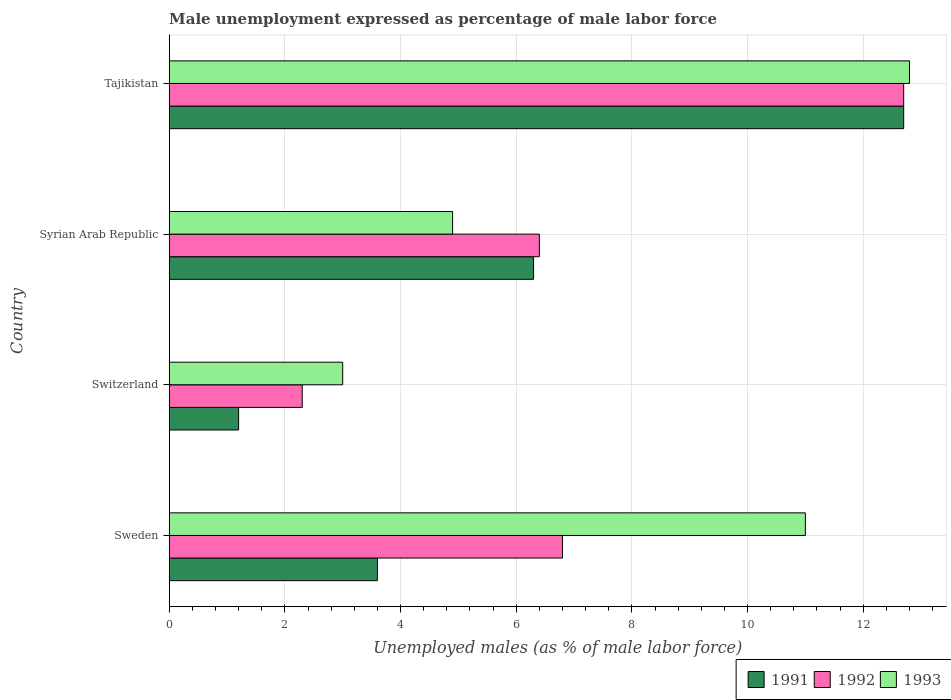How many different coloured bars are there?
Make the answer very short. 3. Are the number of bars per tick equal to the number of legend labels?
Offer a very short reply. Yes. Are the number of bars on each tick of the Y-axis equal?
Your answer should be compact. Yes. How many bars are there on the 4th tick from the top?
Give a very brief answer. 3. What is the label of the 2nd group of bars from the top?
Your answer should be compact. Syrian Arab Republic. In how many cases, is the number of bars for a given country not equal to the number of legend labels?
Keep it short and to the point. 0. What is the unemployment in males in in 1993 in Syrian Arab Republic?
Offer a terse response. 4.9. Across all countries, what is the maximum unemployment in males in in 1992?
Ensure brevity in your answer.  12.7. Across all countries, what is the minimum unemployment in males in in 1993?
Provide a succinct answer. 3. In which country was the unemployment in males in in 1992 maximum?
Make the answer very short. Tajikistan. In which country was the unemployment in males in in 1992 minimum?
Keep it short and to the point. Switzerland. What is the total unemployment in males in in 1993 in the graph?
Your response must be concise. 31.7. What is the difference between the unemployment in males in in 1993 in Syrian Arab Republic and that in Tajikistan?
Offer a very short reply. -7.9. What is the difference between the unemployment in males in in 1991 in Switzerland and the unemployment in males in in 1993 in Sweden?
Your answer should be compact. -9.8. What is the average unemployment in males in in 1992 per country?
Keep it short and to the point. 7.05. What is the difference between the unemployment in males in in 1993 and unemployment in males in in 1992 in Switzerland?
Offer a terse response. 0.7. What is the ratio of the unemployment in males in in 1992 in Sweden to that in Switzerland?
Offer a terse response. 2.96. What is the difference between the highest and the second highest unemployment in males in in 1992?
Your response must be concise. 5.9. What is the difference between the highest and the lowest unemployment in males in in 1991?
Your response must be concise. 11.5. Is it the case that in every country, the sum of the unemployment in males in in 1991 and unemployment in males in in 1992 is greater than the unemployment in males in in 1993?
Your answer should be very brief. No. What is the difference between two consecutive major ticks on the X-axis?
Provide a short and direct response. 2. Does the graph contain any zero values?
Keep it short and to the point. No. Where does the legend appear in the graph?
Your answer should be very brief. Bottom right. What is the title of the graph?
Your answer should be very brief. Male unemployment expressed as percentage of male labor force. Does "1974" appear as one of the legend labels in the graph?
Offer a very short reply. No. What is the label or title of the X-axis?
Your response must be concise. Unemployed males (as % of male labor force). What is the label or title of the Y-axis?
Keep it short and to the point. Country. What is the Unemployed males (as % of male labor force) in 1991 in Sweden?
Give a very brief answer. 3.6. What is the Unemployed males (as % of male labor force) of 1992 in Sweden?
Provide a short and direct response. 6.8. What is the Unemployed males (as % of male labor force) in 1993 in Sweden?
Keep it short and to the point. 11. What is the Unemployed males (as % of male labor force) of 1991 in Switzerland?
Give a very brief answer. 1.2. What is the Unemployed males (as % of male labor force) in 1992 in Switzerland?
Offer a terse response. 2.3. What is the Unemployed males (as % of male labor force) in 1993 in Switzerland?
Your answer should be compact. 3. What is the Unemployed males (as % of male labor force) of 1991 in Syrian Arab Republic?
Ensure brevity in your answer.  6.3. What is the Unemployed males (as % of male labor force) in 1992 in Syrian Arab Republic?
Offer a terse response. 6.4. What is the Unemployed males (as % of male labor force) of 1993 in Syrian Arab Republic?
Provide a short and direct response. 4.9. What is the Unemployed males (as % of male labor force) of 1991 in Tajikistan?
Provide a succinct answer. 12.7. What is the Unemployed males (as % of male labor force) of 1992 in Tajikistan?
Keep it short and to the point. 12.7. What is the Unemployed males (as % of male labor force) in 1993 in Tajikistan?
Offer a terse response. 12.8. Across all countries, what is the maximum Unemployed males (as % of male labor force) in 1991?
Offer a very short reply. 12.7. Across all countries, what is the maximum Unemployed males (as % of male labor force) of 1992?
Your response must be concise. 12.7. Across all countries, what is the maximum Unemployed males (as % of male labor force) in 1993?
Give a very brief answer. 12.8. Across all countries, what is the minimum Unemployed males (as % of male labor force) of 1991?
Make the answer very short. 1.2. Across all countries, what is the minimum Unemployed males (as % of male labor force) in 1992?
Provide a succinct answer. 2.3. Across all countries, what is the minimum Unemployed males (as % of male labor force) of 1993?
Provide a succinct answer. 3. What is the total Unemployed males (as % of male labor force) in 1991 in the graph?
Make the answer very short. 23.8. What is the total Unemployed males (as % of male labor force) of 1992 in the graph?
Give a very brief answer. 28.2. What is the total Unemployed males (as % of male labor force) of 1993 in the graph?
Give a very brief answer. 31.7. What is the difference between the Unemployed males (as % of male labor force) in 1991 in Sweden and that in Switzerland?
Make the answer very short. 2.4. What is the difference between the Unemployed males (as % of male labor force) of 1992 in Sweden and that in Syrian Arab Republic?
Your answer should be very brief. 0.4. What is the difference between the Unemployed males (as % of male labor force) in 1993 in Sweden and that in Syrian Arab Republic?
Make the answer very short. 6.1. What is the difference between the Unemployed males (as % of male labor force) of 1991 in Sweden and that in Tajikistan?
Offer a very short reply. -9.1. What is the difference between the Unemployed males (as % of male labor force) in 1992 in Sweden and that in Tajikistan?
Make the answer very short. -5.9. What is the difference between the Unemployed males (as % of male labor force) of 1992 in Switzerland and that in Syrian Arab Republic?
Your response must be concise. -4.1. What is the difference between the Unemployed males (as % of male labor force) of 1992 in Switzerland and that in Tajikistan?
Your answer should be compact. -10.4. What is the difference between the Unemployed males (as % of male labor force) of 1991 in Syrian Arab Republic and that in Tajikistan?
Keep it short and to the point. -6.4. What is the difference between the Unemployed males (as % of male labor force) of 1992 in Syrian Arab Republic and that in Tajikistan?
Your response must be concise. -6.3. What is the difference between the Unemployed males (as % of male labor force) of 1991 in Sweden and the Unemployed males (as % of male labor force) of 1993 in Switzerland?
Your answer should be very brief. 0.6. What is the difference between the Unemployed males (as % of male labor force) in 1992 in Sweden and the Unemployed males (as % of male labor force) in 1993 in Switzerland?
Make the answer very short. 3.8. What is the difference between the Unemployed males (as % of male labor force) of 1991 in Sweden and the Unemployed males (as % of male labor force) of 1992 in Tajikistan?
Provide a succinct answer. -9.1. What is the difference between the Unemployed males (as % of male labor force) in 1992 in Sweden and the Unemployed males (as % of male labor force) in 1993 in Tajikistan?
Provide a succinct answer. -6. What is the difference between the Unemployed males (as % of male labor force) in 1991 in Switzerland and the Unemployed males (as % of male labor force) in 1992 in Syrian Arab Republic?
Your answer should be compact. -5.2. What is the difference between the Unemployed males (as % of male labor force) in 1991 in Switzerland and the Unemployed males (as % of male labor force) in 1993 in Syrian Arab Republic?
Your answer should be very brief. -3.7. What is the difference between the Unemployed males (as % of male labor force) in 1992 in Switzerland and the Unemployed males (as % of male labor force) in 1993 in Syrian Arab Republic?
Your response must be concise. -2.6. What is the difference between the Unemployed males (as % of male labor force) in 1991 in Switzerland and the Unemployed males (as % of male labor force) in 1992 in Tajikistan?
Your response must be concise. -11.5. What is the difference between the Unemployed males (as % of male labor force) of 1991 in Switzerland and the Unemployed males (as % of male labor force) of 1993 in Tajikistan?
Your answer should be very brief. -11.6. What is the average Unemployed males (as % of male labor force) in 1991 per country?
Keep it short and to the point. 5.95. What is the average Unemployed males (as % of male labor force) of 1992 per country?
Provide a short and direct response. 7.05. What is the average Unemployed males (as % of male labor force) in 1993 per country?
Give a very brief answer. 7.92. What is the difference between the Unemployed males (as % of male labor force) in 1992 and Unemployed males (as % of male labor force) in 1993 in Sweden?
Give a very brief answer. -4.2. What is the difference between the Unemployed males (as % of male labor force) in 1991 and Unemployed males (as % of male labor force) in 1993 in Switzerland?
Offer a terse response. -1.8. What is the difference between the Unemployed males (as % of male labor force) in 1992 and Unemployed males (as % of male labor force) in 1993 in Switzerland?
Give a very brief answer. -0.7. What is the difference between the Unemployed males (as % of male labor force) in 1991 and Unemployed males (as % of male labor force) in 1993 in Tajikistan?
Offer a very short reply. -0.1. What is the ratio of the Unemployed males (as % of male labor force) of 1991 in Sweden to that in Switzerland?
Your response must be concise. 3. What is the ratio of the Unemployed males (as % of male labor force) in 1992 in Sweden to that in Switzerland?
Give a very brief answer. 2.96. What is the ratio of the Unemployed males (as % of male labor force) in 1993 in Sweden to that in Switzerland?
Give a very brief answer. 3.67. What is the ratio of the Unemployed males (as % of male labor force) in 1993 in Sweden to that in Syrian Arab Republic?
Your answer should be compact. 2.24. What is the ratio of the Unemployed males (as % of male labor force) of 1991 in Sweden to that in Tajikistan?
Provide a succinct answer. 0.28. What is the ratio of the Unemployed males (as % of male labor force) of 1992 in Sweden to that in Tajikistan?
Offer a very short reply. 0.54. What is the ratio of the Unemployed males (as % of male labor force) in 1993 in Sweden to that in Tajikistan?
Provide a short and direct response. 0.86. What is the ratio of the Unemployed males (as % of male labor force) in 1991 in Switzerland to that in Syrian Arab Republic?
Make the answer very short. 0.19. What is the ratio of the Unemployed males (as % of male labor force) in 1992 in Switzerland to that in Syrian Arab Republic?
Provide a short and direct response. 0.36. What is the ratio of the Unemployed males (as % of male labor force) in 1993 in Switzerland to that in Syrian Arab Republic?
Offer a very short reply. 0.61. What is the ratio of the Unemployed males (as % of male labor force) in 1991 in Switzerland to that in Tajikistan?
Give a very brief answer. 0.09. What is the ratio of the Unemployed males (as % of male labor force) in 1992 in Switzerland to that in Tajikistan?
Give a very brief answer. 0.18. What is the ratio of the Unemployed males (as % of male labor force) in 1993 in Switzerland to that in Tajikistan?
Provide a succinct answer. 0.23. What is the ratio of the Unemployed males (as % of male labor force) of 1991 in Syrian Arab Republic to that in Tajikistan?
Keep it short and to the point. 0.5. What is the ratio of the Unemployed males (as % of male labor force) in 1992 in Syrian Arab Republic to that in Tajikistan?
Your answer should be very brief. 0.5. What is the ratio of the Unemployed males (as % of male labor force) in 1993 in Syrian Arab Republic to that in Tajikistan?
Your answer should be very brief. 0.38. What is the difference between the highest and the second highest Unemployed males (as % of male labor force) of 1992?
Your answer should be compact. 5.9. What is the difference between the highest and the lowest Unemployed males (as % of male labor force) of 1991?
Offer a terse response. 11.5. 